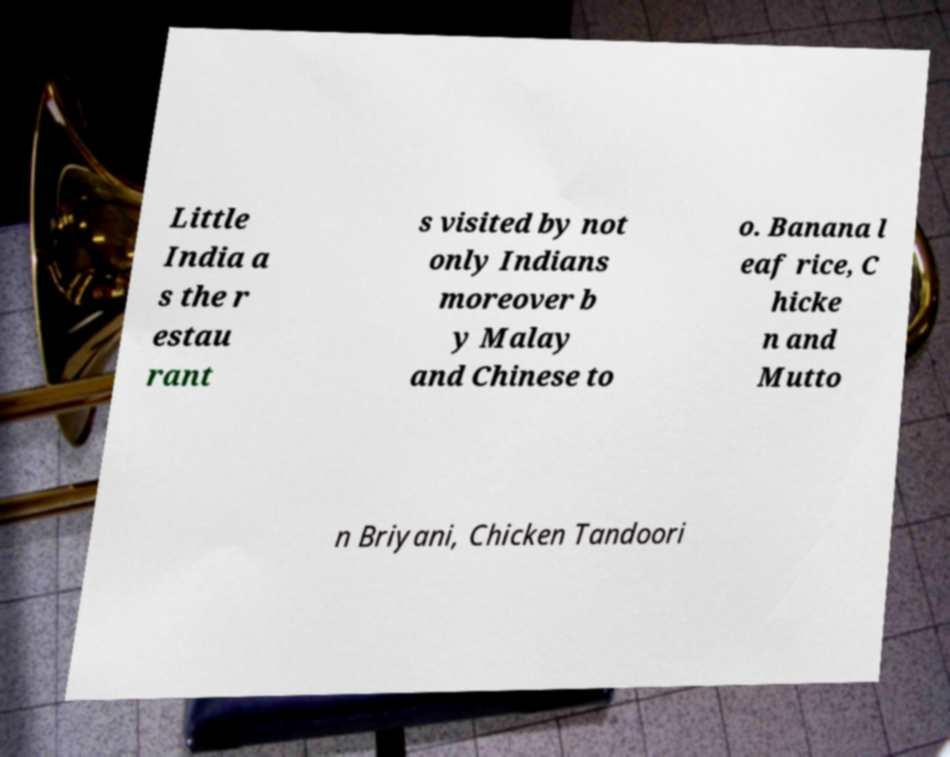What messages or text are displayed in this image? I need them in a readable, typed format. Little India a s the r estau rant s visited by not only Indians moreover b y Malay and Chinese to o. Banana l eaf rice, C hicke n and Mutto n Briyani, Chicken Tandoori 